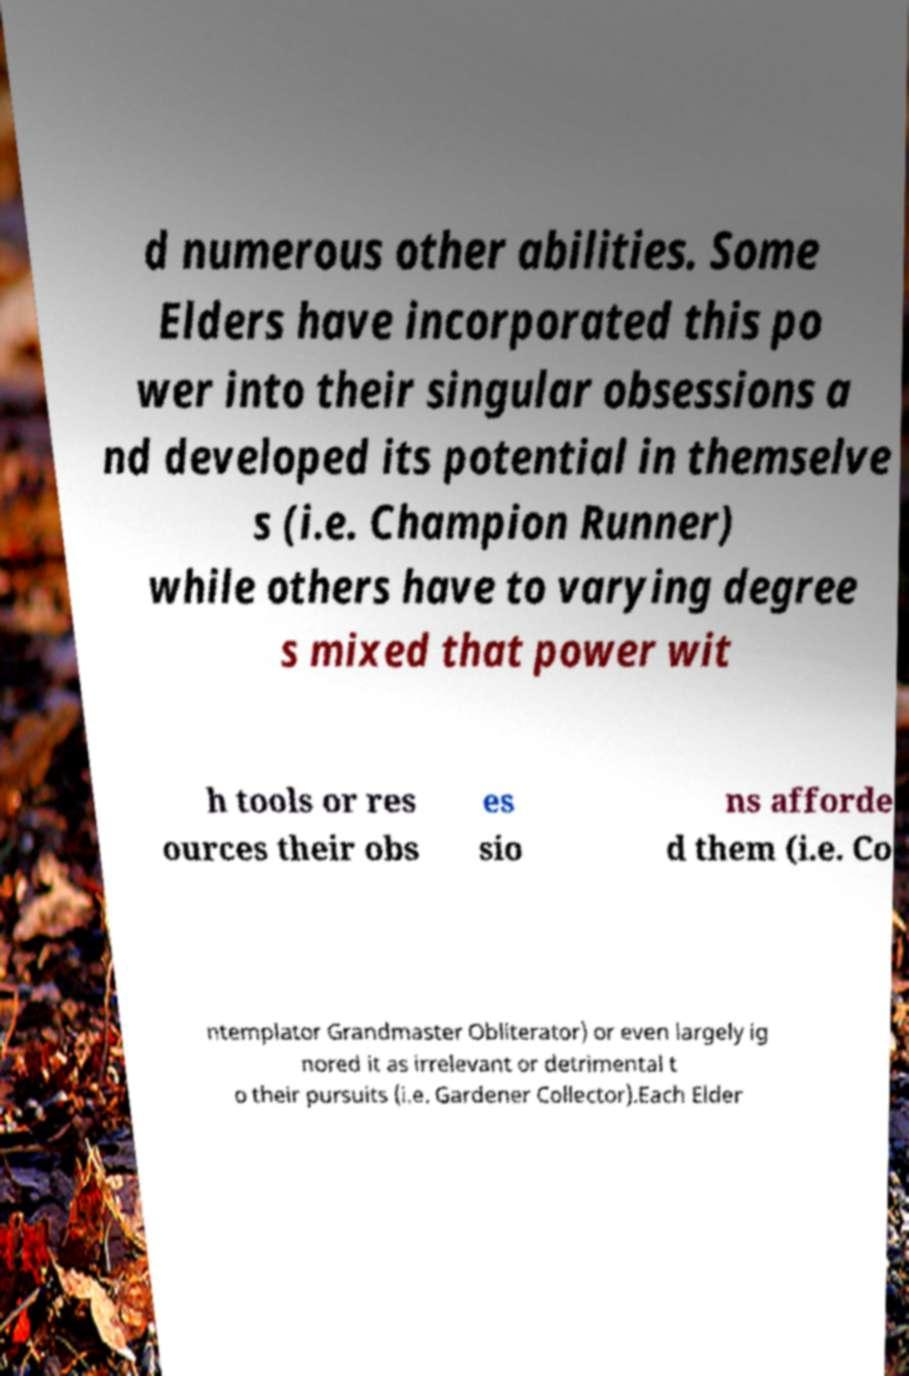Can you accurately transcribe the text from the provided image for me? d numerous other abilities. Some Elders have incorporated this po wer into their singular obsessions a nd developed its potential in themselve s (i.e. Champion Runner) while others have to varying degree s mixed that power wit h tools or res ources their obs es sio ns afforde d them (i.e. Co ntemplator Grandmaster Obliterator) or even largely ig nored it as irrelevant or detrimental t o their pursuits (i.e. Gardener Collector).Each Elder 